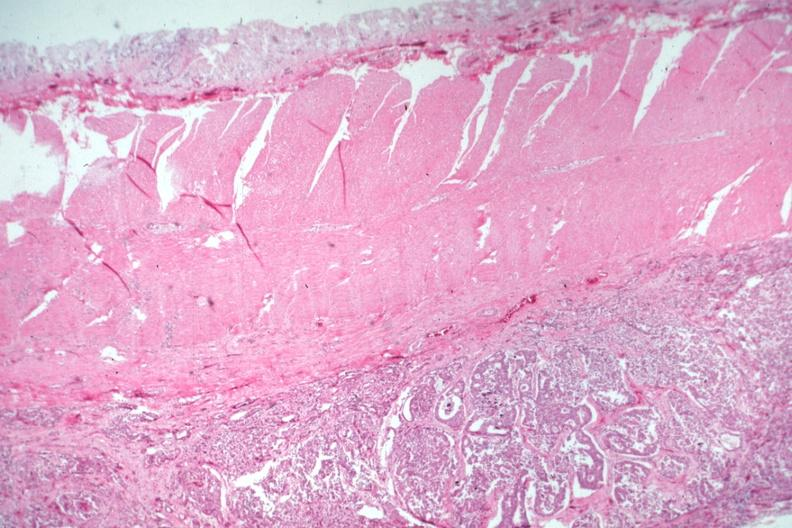what is present?
Answer the question using a single word or phrase. Colon 